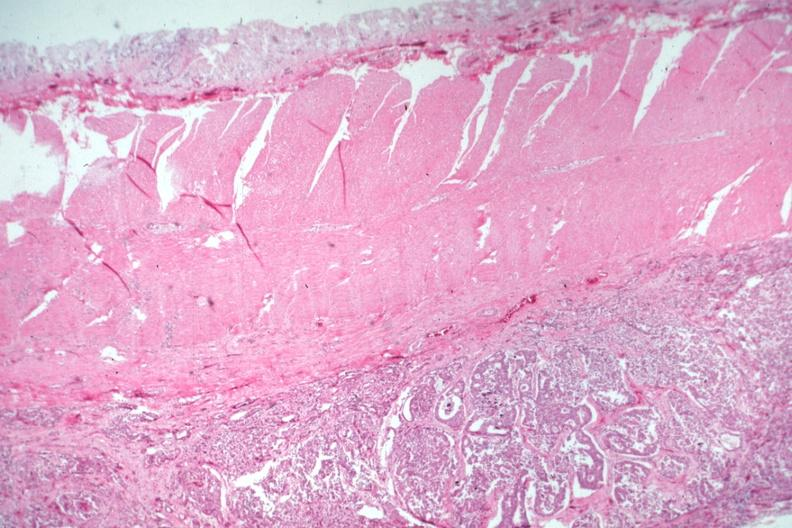what is present?
Answer the question using a single word or phrase. Colon 